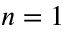Convert formula to latex. <formula><loc_0><loc_0><loc_500><loc_500>n = 1</formula> 